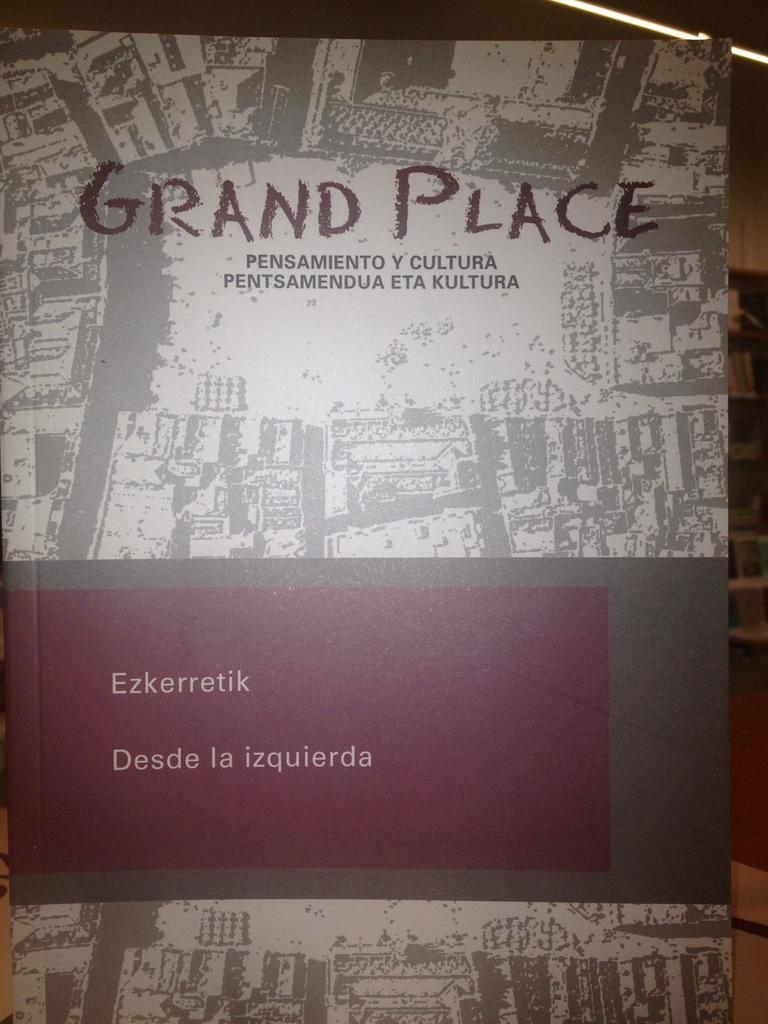In one or two sentences, can you explain what this image depicts? In this image we can see a book. 